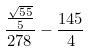<formula> <loc_0><loc_0><loc_500><loc_500>\frac { \frac { \sqrt { 5 5 } } { 5 } } { 2 7 8 } - \frac { 1 4 5 } { 4 }</formula> 